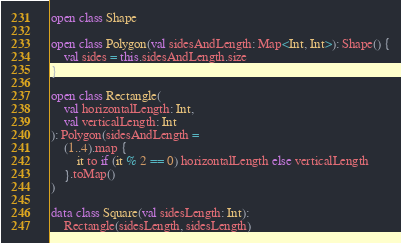Convert code to text. <code><loc_0><loc_0><loc_500><loc_500><_Kotlin_>open class Shape

open class Polygon(val sidesAndLength: Map<Int, Int>): Shape() {
	val sides = this.sidesAndLength.size
}

open class Rectangle(
	val horizontalLength: Int, 
	val verticalLength: Int
): Polygon(sidesAndLength = 
	(1..4).map { 
		it to if (it % 2 == 0) horizontalLength else verticalLength 
	}.toMap()
)

data class Square(val sidesLength: Int): 
	Rectangle(sidesLength, sidesLength)</code> 